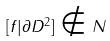<formula> <loc_0><loc_0><loc_500><loc_500>[ f | \partial D ^ { 2 } ] \notin N</formula> 